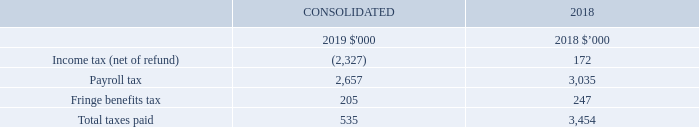Australian taxes paid summary
Tax payments made by iSelect for the 2019 and 2018 financial years are summarised below.
What is the Income tax (net of refund) for 2019 and 2018 respectively?
Answer scale should be: thousand. (2,327), 172. What is the payroll tax for 2019 and 2018 respectively?
Answer scale should be: thousand. 2,657, 3,035. What is the total taxes paid for 2019 and 2018 respectively?
Answer scale should be: thousand. 535, 3,454. What is the percentage change in the payroll tax from 2018 to 2019?
Answer scale should be: percent. (2,657-3,035)/3,035
Answer: -12.45. What is the percentage change in the fringe benefits tax from 2018 to 2019?
Answer scale should be: percent. (205-247)/247
Answer: -17. What is the percentage change in the total taxes paid from 2018 to 2019?
Answer scale should be: percent. (535-3,454)/3,454
Answer: -84.51. 